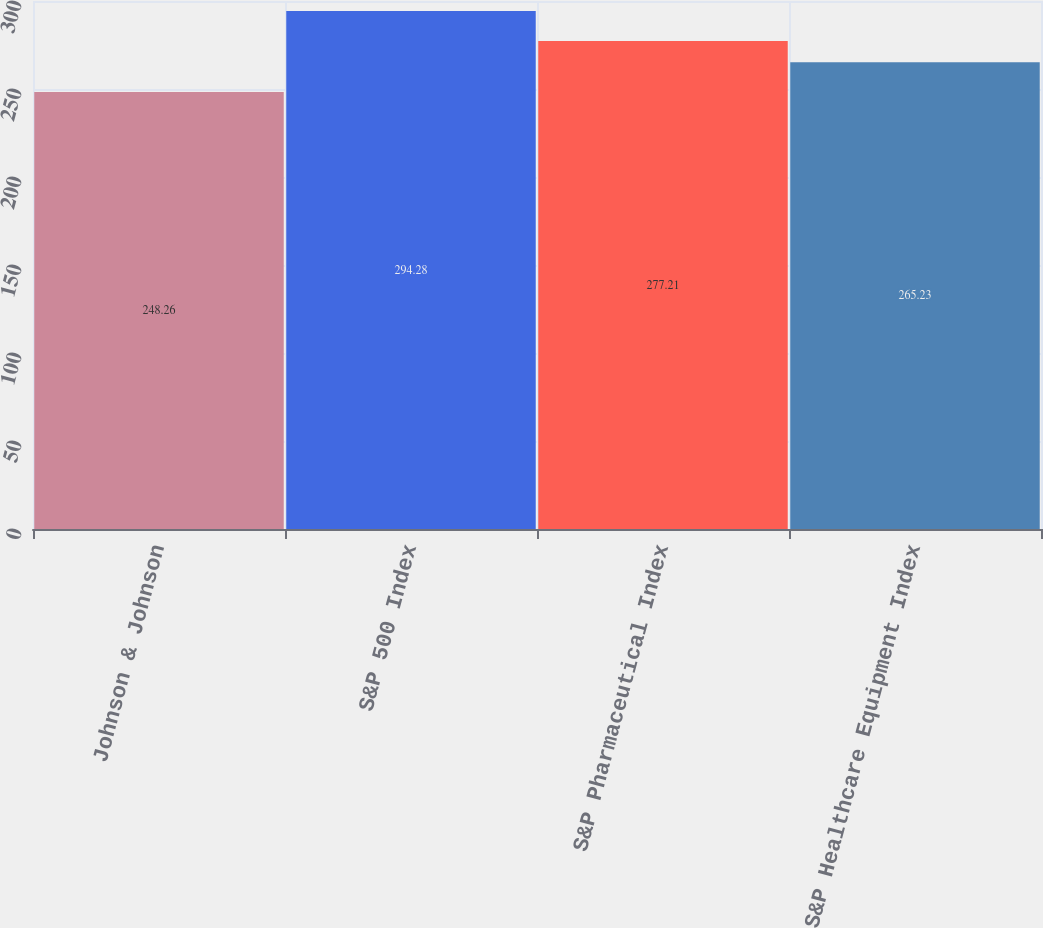Convert chart. <chart><loc_0><loc_0><loc_500><loc_500><bar_chart><fcel>Johnson & Johnson<fcel>S&P 500 Index<fcel>S&P Pharmaceutical Index<fcel>S&P Healthcare Equipment Index<nl><fcel>248.26<fcel>294.28<fcel>277.21<fcel>265.23<nl></chart> 